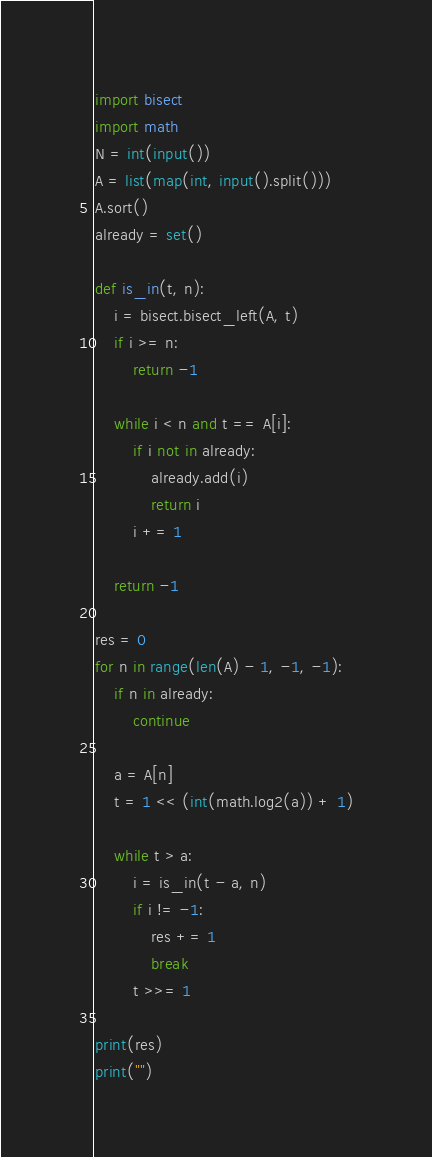Convert code to text. <code><loc_0><loc_0><loc_500><loc_500><_Python_>import bisect
import math
N = int(input())
A = list(map(int, input().split()))
A.sort()
already = set()

def is_in(t, n):
    i = bisect.bisect_left(A, t)
    if i >= n:
        return -1

    while i < n and t == A[i]:
        if i not in already:
            already.add(i)
            return i
        i += 1

    return -1

res = 0
for n in range(len(A) - 1, -1, -1):
    if n in already:
        continue

    a = A[n]
    t = 1 << (int(math.log2(a)) + 1)

    while t > a:
        i = is_in(t - a, n)
        if i != -1:
            res += 1
            break
        t >>= 1

print(res)
print("")
</code> 